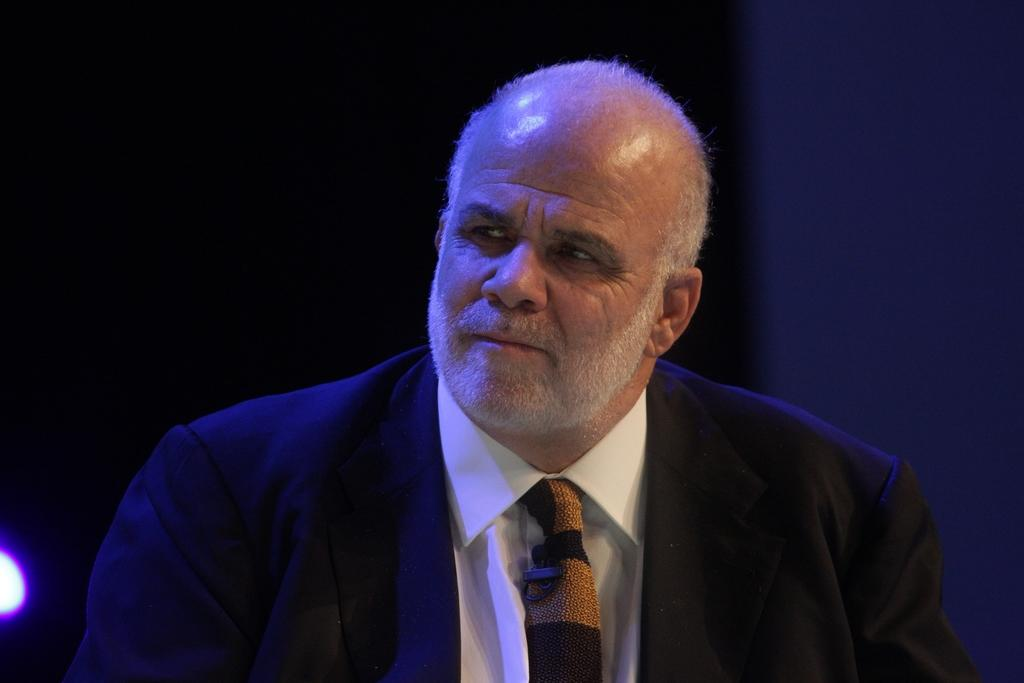Who is in the picture? There is a man in the picture. What is the man wearing? The man is wearing a coat and a tie. Where is the light located in the picture? The light is on the left side of the picture. What is the color of the background in the picture? The background of the picture is black. Can you see any letters on the shelf in the picture? There is no shelf present in the image, so it is not possible to see any letters on a shelf. 